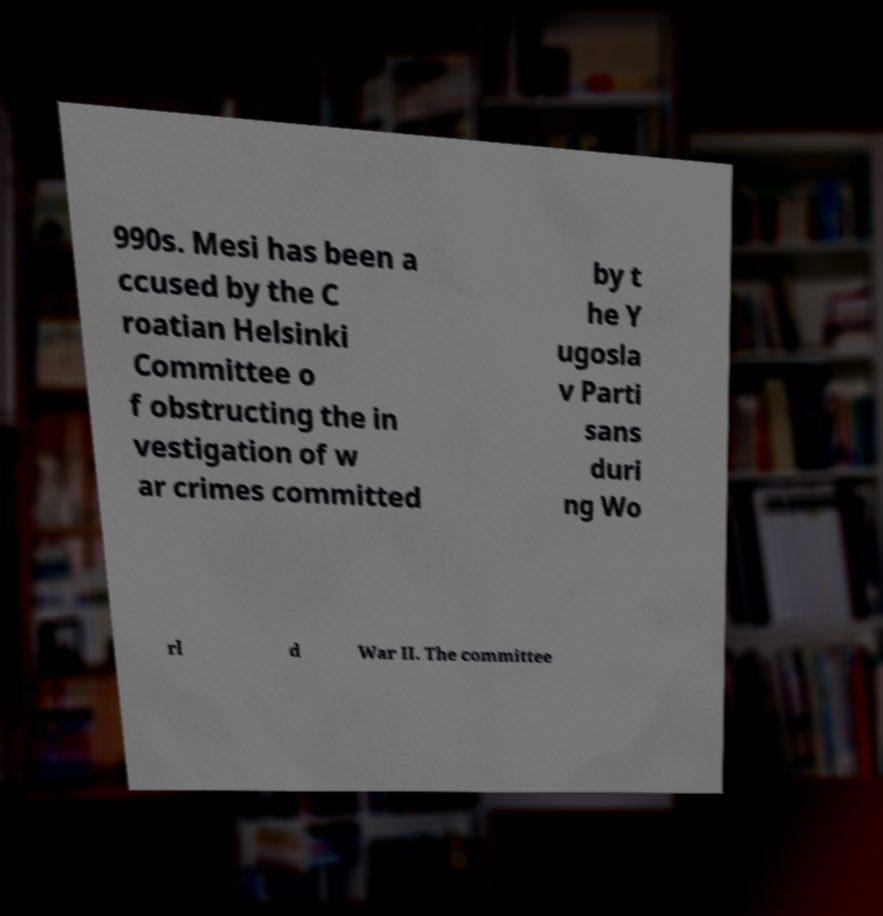Please read and relay the text visible in this image. What does it say? 990s. Mesi has been a ccused by the C roatian Helsinki Committee o f obstructing the in vestigation of w ar crimes committed by t he Y ugosla v Parti sans duri ng Wo rl d War II. The committee 